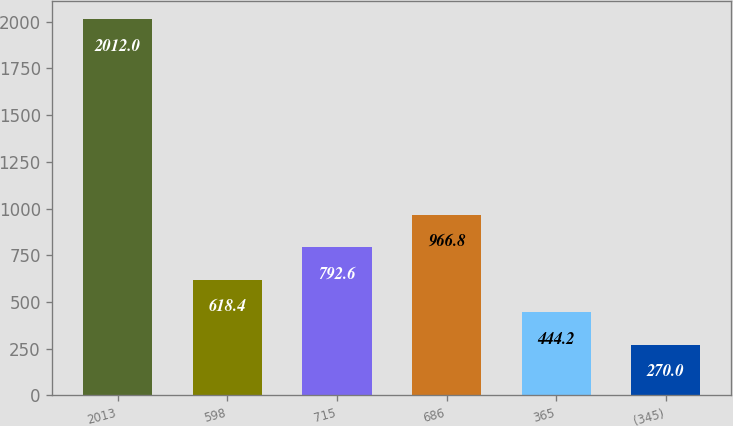Convert chart. <chart><loc_0><loc_0><loc_500><loc_500><bar_chart><fcel>2013<fcel>598<fcel>715<fcel>686<fcel>365<fcel>(345)<nl><fcel>2012<fcel>618.4<fcel>792.6<fcel>966.8<fcel>444.2<fcel>270<nl></chart> 